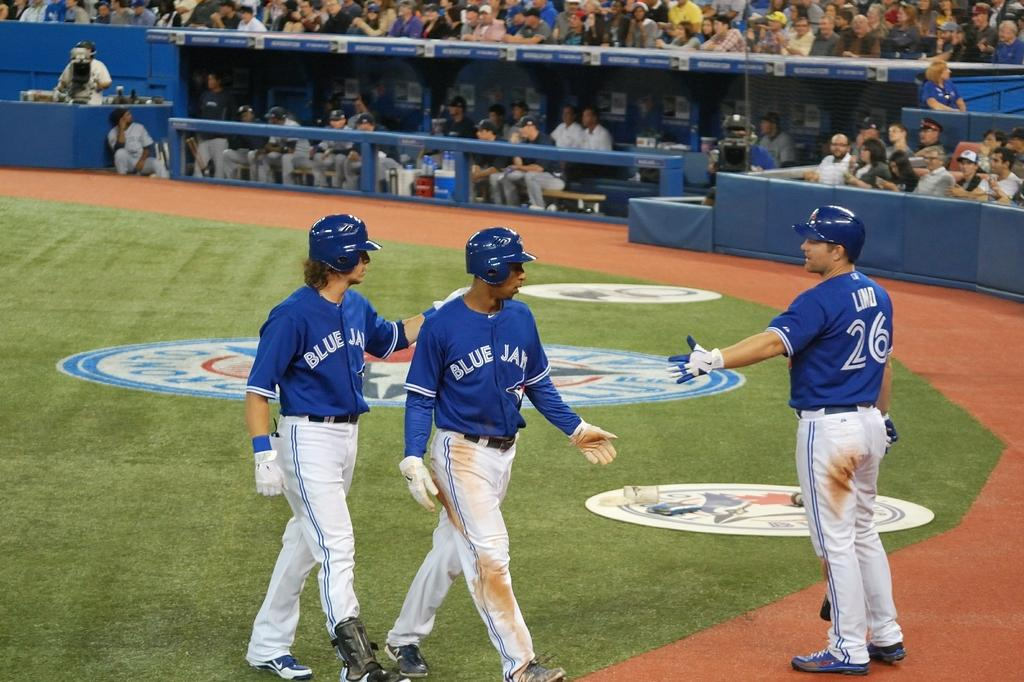<image>
Offer a succinct explanation of the picture presented. a few Blue Jays players that are walking on the field 